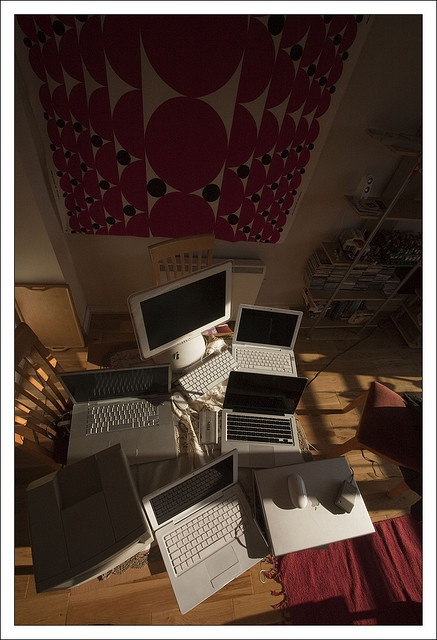Describe the objects in this image and their specific colors. I can see laptop in black, maroon, and gray tones, laptop in black, darkgray, gray, and tan tones, laptop in black and gray tones, tv in black, gray, lightgray, and maroon tones, and laptop in black and lightgray tones in this image. 